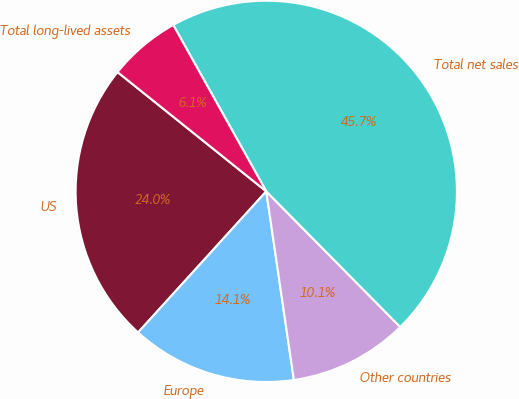Convert chart to OTSL. <chart><loc_0><loc_0><loc_500><loc_500><pie_chart><fcel>US<fcel>Europe<fcel>Other countries<fcel>Total net sales<fcel>Total long-lived assets<nl><fcel>24.02%<fcel>14.05%<fcel>10.09%<fcel>45.71%<fcel>6.13%<nl></chart> 